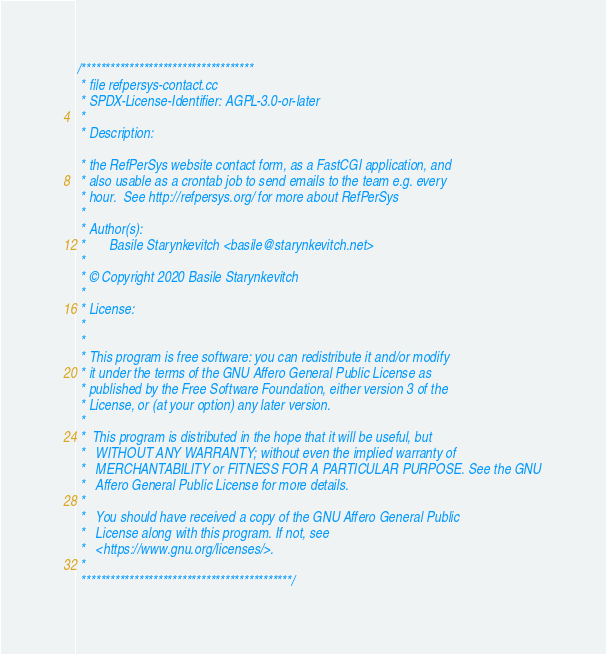Convert code to text. <code><loc_0><loc_0><loc_500><loc_500><_C++_>/************************************
 * file refpersys-contact.cc 
 * SPDX-License-Identifier: AGPL-3.0-or-later
 *
 * Description:

 * the RefPerSys website contact form, as a FastCGI application, and
 * also usable as a crontab job to send emails to the team e.g. every
 * hour.  See http://refpersys.org/ for more about RefPerSys
 *
 * Author(s):
 *       Basile Starynkevitch <basile@starynkevitch.net>
 *
 * © Copyright 2020 Basile Starynkevitch
 *
 * License:
 *
 *
 * This program is free software: you can redistribute it and/or modify
 * it under the terms of the GNU Affero General Public License as
 * published by the Free Software Foundation, either version 3 of the
 * License, or (at your option) any later version.
 *
 *  This program is distributed in the hope that it will be useful, but
 *   WITHOUT ANY WARRANTY; without even the implied warranty of
 *   MERCHANTABILITY or FITNESS FOR A PARTICULAR PURPOSE. See the GNU
 *   Affero General Public License for more details.
 *
 *   You should have received a copy of the GNU Affero General Public
 *   License along with this program. If not, see
 *   <https://www.gnu.org/licenses/>.
 *
 ********************************************/
</code> 